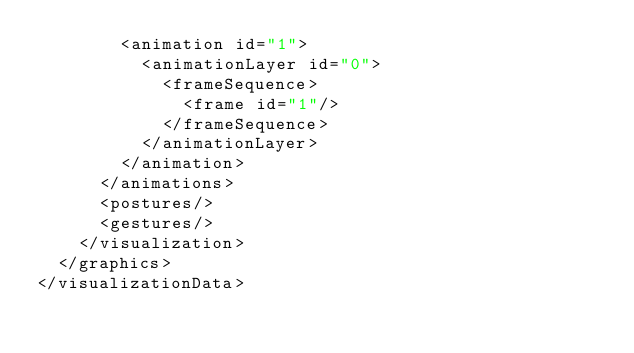<code> <loc_0><loc_0><loc_500><loc_500><_XML_>        <animation id="1">
          <animationLayer id="0">
            <frameSequence>
              <frame id="1"/>
            </frameSequence>
          </animationLayer>
        </animation>
      </animations>
      <postures/>
      <gestures/>
    </visualization>
  </graphics>
</visualizationData></code> 